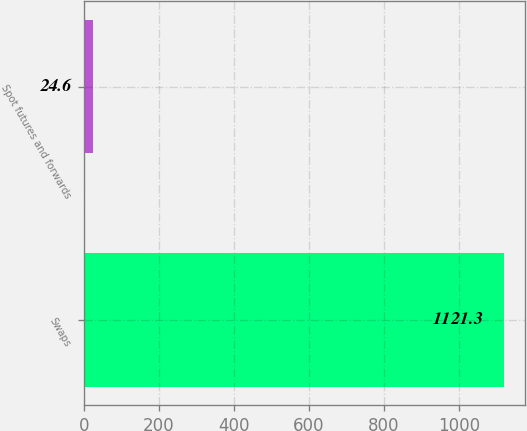Convert chart. <chart><loc_0><loc_0><loc_500><loc_500><bar_chart><fcel>Swaps<fcel>Spot futures and forwards<nl><fcel>1121.3<fcel>24.6<nl></chart> 